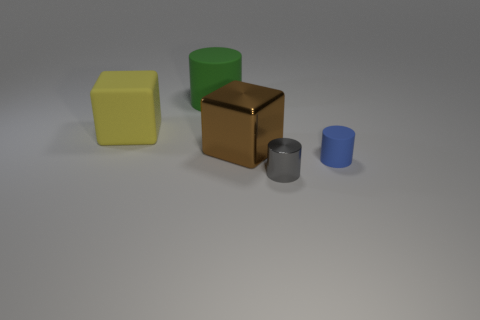Add 1 big brown shiny objects. How many objects exist? 6 Subtract all cubes. How many objects are left? 3 Add 2 large yellow matte blocks. How many large yellow matte blocks exist? 3 Subtract 0 purple spheres. How many objects are left? 5 Subtract all brown metallic objects. Subtract all gray metallic cylinders. How many objects are left? 3 Add 1 gray cylinders. How many gray cylinders are left? 2 